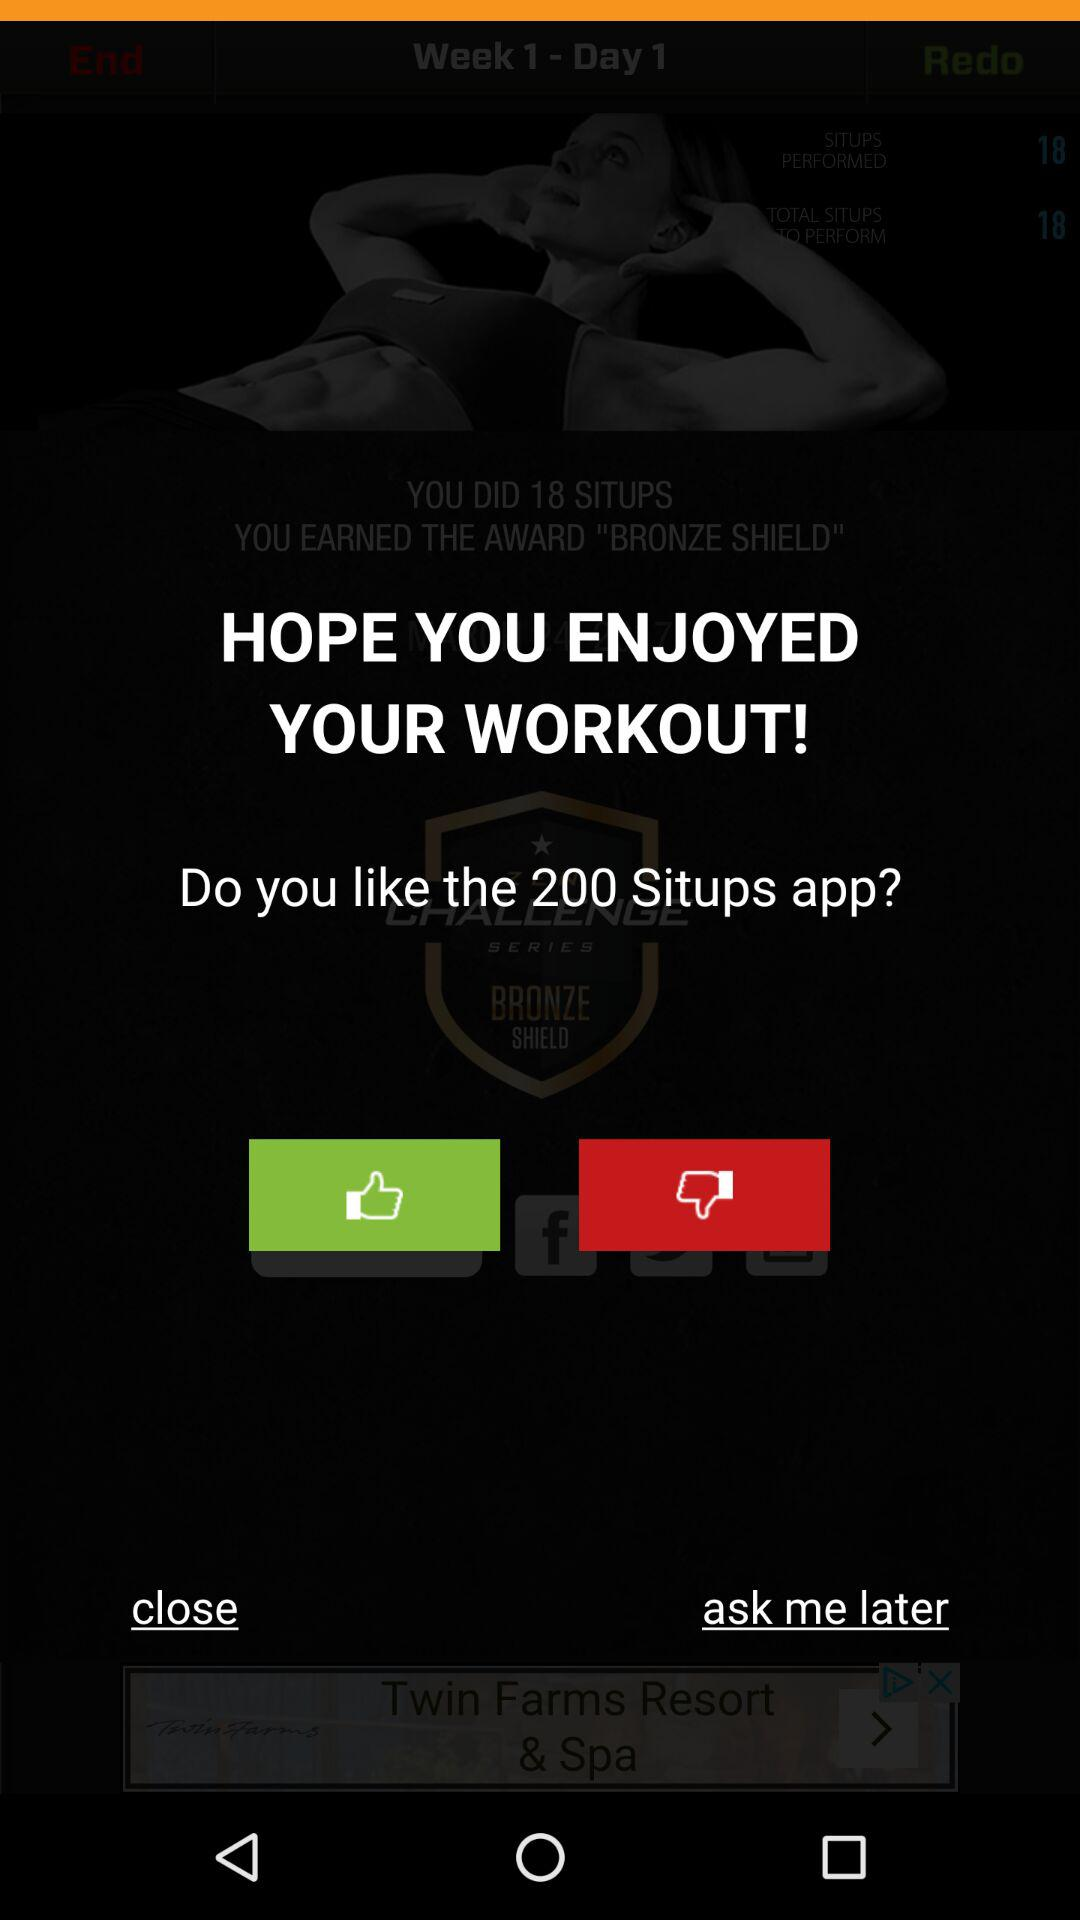How many situps are targeted on Wednesday? The situps target is 36. 